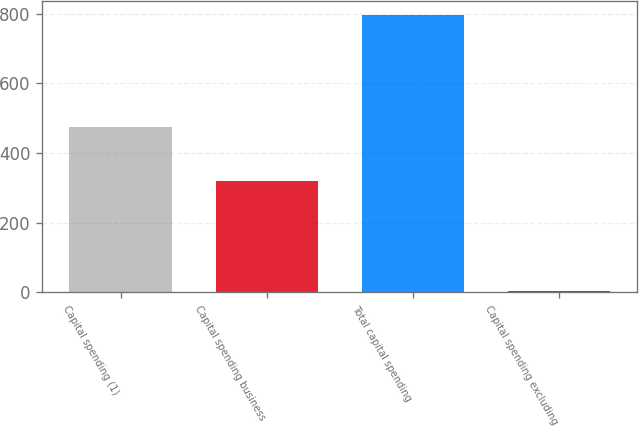Convert chart. <chart><loc_0><loc_0><loc_500><loc_500><bar_chart><fcel>Capital spending (1)<fcel>Capital spending business<fcel>Total capital spending<fcel>Capital spending excluding<nl><fcel>476<fcel>320<fcel>796<fcel>3.1<nl></chart> 